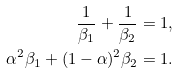Convert formula to latex. <formula><loc_0><loc_0><loc_500><loc_500>\frac { 1 } { \beta _ { 1 } } + \frac { 1 } { \beta _ { 2 } } & = 1 , \\ \alpha ^ { 2 } \beta _ { 1 } + ( 1 - \alpha ) ^ { 2 } \beta _ { 2 } & = 1 .</formula> 